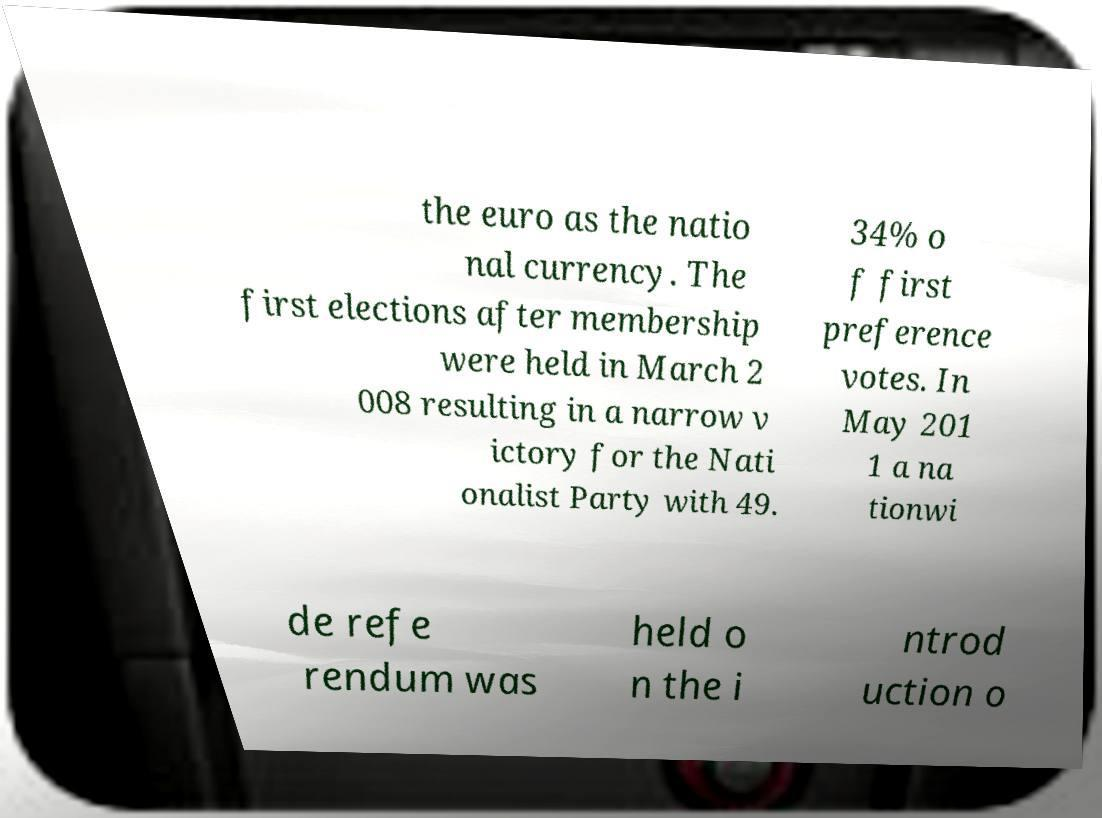Can you read and provide the text displayed in the image?This photo seems to have some interesting text. Can you extract and type it out for me? the euro as the natio nal currency. The first elections after membership were held in March 2 008 resulting in a narrow v ictory for the Nati onalist Party with 49. 34% o f first preference votes. In May 201 1 a na tionwi de refe rendum was held o n the i ntrod uction o 